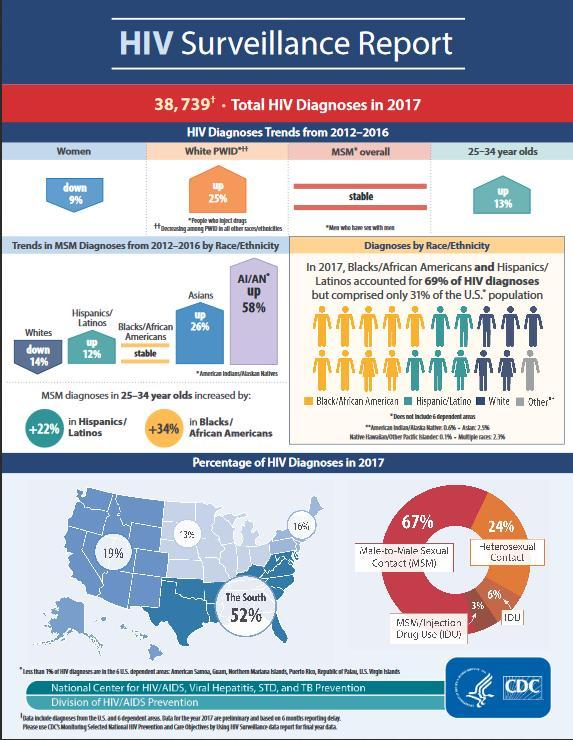Which area in the United States has high percentage of HIV diagnoses in 2017?
Answer the question with a short phrase. The South Which is the second highest reason for transmission as shown in the chart? Heterosexual Contact For which group has the HIV diagnoses trends gone down? Women 